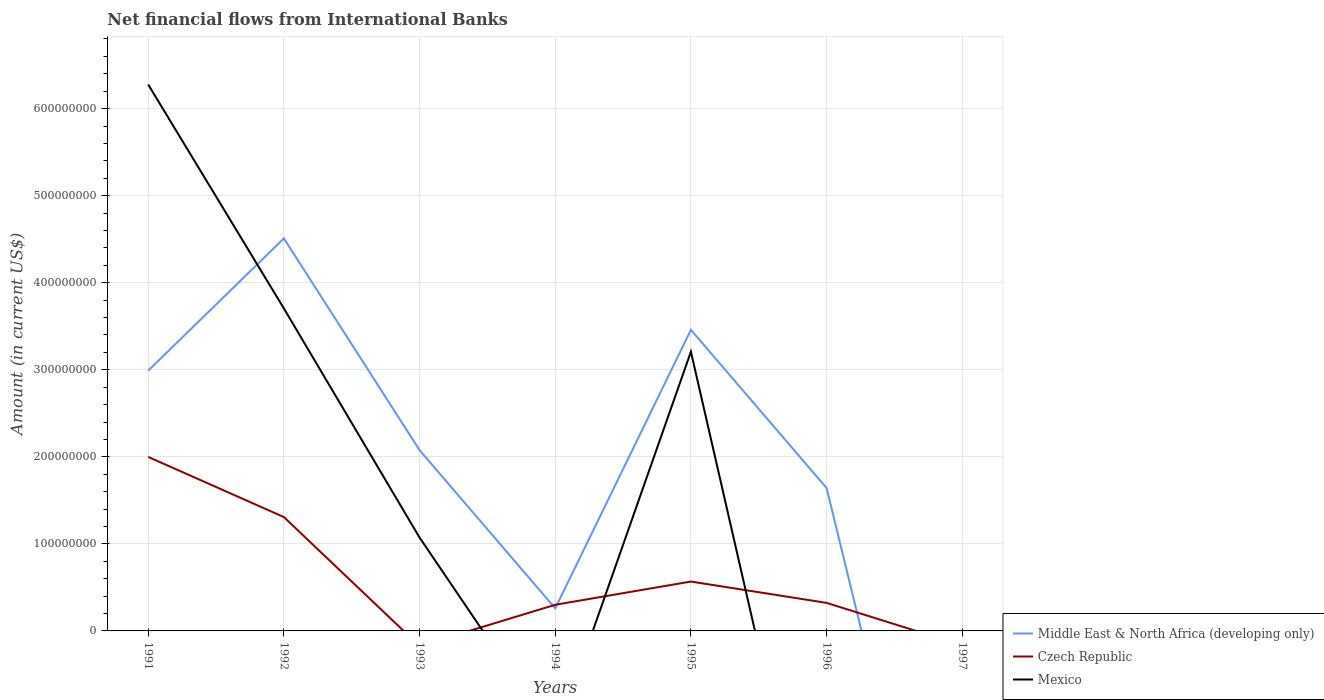What is the total net financial aid flows in Middle East & North Africa (developing only) in the graph?
Your answer should be very brief. 9.13e+07. What is the difference between the highest and the second highest net financial aid flows in Mexico?
Offer a very short reply. 6.28e+08. What is the difference between the highest and the lowest net financial aid flows in Czech Republic?
Offer a very short reply. 2. How many lines are there?
Give a very brief answer. 3. How many years are there in the graph?
Provide a succinct answer. 7. Does the graph contain any zero values?
Offer a very short reply. Yes. Does the graph contain grids?
Your answer should be very brief. Yes. How many legend labels are there?
Make the answer very short. 3. How are the legend labels stacked?
Offer a terse response. Vertical. What is the title of the graph?
Provide a succinct answer. Net financial flows from International Banks. Does "Belgium" appear as one of the legend labels in the graph?
Provide a succinct answer. No. What is the Amount (in current US$) in Middle East & North Africa (developing only) in 1991?
Provide a succinct answer. 2.99e+08. What is the Amount (in current US$) of Czech Republic in 1991?
Your answer should be very brief. 2.00e+08. What is the Amount (in current US$) in Mexico in 1991?
Make the answer very short. 6.28e+08. What is the Amount (in current US$) in Middle East & North Africa (developing only) in 1992?
Give a very brief answer. 4.51e+08. What is the Amount (in current US$) in Czech Republic in 1992?
Keep it short and to the point. 1.31e+08. What is the Amount (in current US$) in Mexico in 1992?
Give a very brief answer. 3.70e+08. What is the Amount (in current US$) in Middle East & North Africa (developing only) in 1993?
Provide a short and direct response. 2.08e+08. What is the Amount (in current US$) of Mexico in 1993?
Offer a terse response. 1.07e+08. What is the Amount (in current US$) of Middle East & North Africa (developing only) in 1994?
Provide a succinct answer. 2.59e+07. What is the Amount (in current US$) of Czech Republic in 1994?
Offer a very short reply. 3.00e+07. What is the Amount (in current US$) in Middle East & North Africa (developing only) in 1995?
Offer a very short reply. 3.46e+08. What is the Amount (in current US$) in Czech Republic in 1995?
Ensure brevity in your answer.  5.67e+07. What is the Amount (in current US$) of Mexico in 1995?
Offer a very short reply. 3.21e+08. What is the Amount (in current US$) in Middle East & North Africa (developing only) in 1996?
Your answer should be very brief. 1.64e+08. What is the Amount (in current US$) of Czech Republic in 1996?
Your response must be concise. 3.22e+07. What is the Amount (in current US$) in Middle East & North Africa (developing only) in 1997?
Make the answer very short. 0. What is the Amount (in current US$) of Czech Republic in 1997?
Keep it short and to the point. 0. Across all years, what is the maximum Amount (in current US$) of Middle East & North Africa (developing only)?
Offer a very short reply. 4.51e+08. Across all years, what is the maximum Amount (in current US$) of Czech Republic?
Provide a short and direct response. 2.00e+08. Across all years, what is the maximum Amount (in current US$) in Mexico?
Ensure brevity in your answer.  6.28e+08. What is the total Amount (in current US$) of Middle East & North Africa (developing only) in the graph?
Provide a succinct answer. 1.49e+09. What is the total Amount (in current US$) of Czech Republic in the graph?
Your response must be concise. 4.50e+08. What is the total Amount (in current US$) in Mexico in the graph?
Offer a terse response. 1.43e+09. What is the difference between the Amount (in current US$) in Middle East & North Africa (developing only) in 1991 and that in 1992?
Offer a very short reply. -1.52e+08. What is the difference between the Amount (in current US$) in Czech Republic in 1991 and that in 1992?
Make the answer very short. 6.91e+07. What is the difference between the Amount (in current US$) in Mexico in 1991 and that in 1992?
Ensure brevity in your answer.  2.57e+08. What is the difference between the Amount (in current US$) in Middle East & North Africa (developing only) in 1991 and that in 1993?
Your answer should be compact. 9.13e+07. What is the difference between the Amount (in current US$) in Mexico in 1991 and that in 1993?
Offer a very short reply. 5.20e+08. What is the difference between the Amount (in current US$) in Middle East & North Africa (developing only) in 1991 and that in 1994?
Make the answer very short. 2.73e+08. What is the difference between the Amount (in current US$) of Czech Republic in 1991 and that in 1994?
Your response must be concise. 1.70e+08. What is the difference between the Amount (in current US$) of Middle East & North Africa (developing only) in 1991 and that in 1995?
Your answer should be very brief. -4.69e+07. What is the difference between the Amount (in current US$) of Czech Republic in 1991 and that in 1995?
Keep it short and to the point. 1.43e+08. What is the difference between the Amount (in current US$) of Mexico in 1991 and that in 1995?
Your response must be concise. 3.07e+08. What is the difference between the Amount (in current US$) in Middle East & North Africa (developing only) in 1991 and that in 1996?
Give a very brief answer. 1.35e+08. What is the difference between the Amount (in current US$) of Czech Republic in 1991 and that in 1996?
Your response must be concise. 1.68e+08. What is the difference between the Amount (in current US$) of Middle East & North Africa (developing only) in 1992 and that in 1993?
Give a very brief answer. 2.43e+08. What is the difference between the Amount (in current US$) in Mexico in 1992 and that in 1993?
Make the answer very short. 2.63e+08. What is the difference between the Amount (in current US$) of Middle East & North Africa (developing only) in 1992 and that in 1994?
Offer a very short reply. 4.25e+08. What is the difference between the Amount (in current US$) in Czech Republic in 1992 and that in 1994?
Provide a short and direct response. 1.01e+08. What is the difference between the Amount (in current US$) in Middle East & North Africa (developing only) in 1992 and that in 1995?
Offer a very short reply. 1.05e+08. What is the difference between the Amount (in current US$) in Czech Republic in 1992 and that in 1995?
Offer a terse response. 7.41e+07. What is the difference between the Amount (in current US$) in Mexico in 1992 and that in 1995?
Keep it short and to the point. 4.97e+07. What is the difference between the Amount (in current US$) in Middle East & North Africa (developing only) in 1992 and that in 1996?
Offer a very short reply. 2.87e+08. What is the difference between the Amount (in current US$) in Czech Republic in 1992 and that in 1996?
Your response must be concise. 9.86e+07. What is the difference between the Amount (in current US$) of Middle East & North Africa (developing only) in 1993 and that in 1994?
Your answer should be very brief. 1.82e+08. What is the difference between the Amount (in current US$) of Middle East & North Africa (developing only) in 1993 and that in 1995?
Your response must be concise. -1.38e+08. What is the difference between the Amount (in current US$) of Mexico in 1993 and that in 1995?
Give a very brief answer. -2.13e+08. What is the difference between the Amount (in current US$) in Middle East & North Africa (developing only) in 1993 and that in 1996?
Make the answer very short. 4.35e+07. What is the difference between the Amount (in current US$) of Middle East & North Africa (developing only) in 1994 and that in 1995?
Keep it short and to the point. -3.20e+08. What is the difference between the Amount (in current US$) in Czech Republic in 1994 and that in 1995?
Offer a very short reply. -2.67e+07. What is the difference between the Amount (in current US$) of Middle East & North Africa (developing only) in 1994 and that in 1996?
Provide a succinct answer. -1.38e+08. What is the difference between the Amount (in current US$) in Czech Republic in 1994 and that in 1996?
Provide a succinct answer. -2.19e+06. What is the difference between the Amount (in current US$) of Middle East & North Africa (developing only) in 1995 and that in 1996?
Make the answer very short. 1.82e+08. What is the difference between the Amount (in current US$) in Czech Republic in 1995 and that in 1996?
Provide a succinct answer. 2.45e+07. What is the difference between the Amount (in current US$) in Middle East & North Africa (developing only) in 1991 and the Amount (in current US$) in Czech Republic in 1992?
Your response must be concise. 1.68e+08. What is the difference between the Amount (in current US$) in Middle East & North Africa (developing only) in 1991 and the Amount (in current US$) in Mexico in 1992?
Provide a succinct answer. -7.15e+07. What is the difference between the Amount (in current US$) in Czech Republic in 1991 and the Amount (in current US$) in Mexico in 1992?
Provide a succinct answer. -1.71e+08. What is the difference between the Amount (in current US$) in Middle East & North Africa (developing only) in 1991 and the Amount (in current US$) in Mexico in 1993?
Give a very brief answer. 1.92e+08. What is the difference between the Amount (in current US$) in Czech Republic in 1991 and the Amount (in current US$) in Mexico in 1993?
Ensure brevity in your answer.  9.26e+07. What is the difference between the Amount (in current US$) of Middle East & North Africa (developing only) in 1991 and the Amount (in current US$) of Czech Republic in 1994?
Offer a terse response. 2.69e+08. What is the difference between the Amount (in current US$) in Middle East & North Africa (developing only) in 1991 and the Amount (in current US$) in Czech Republic in 1995?
Provide a succinct answer. 2.42e+08. What is the difference between the Amount (in current US$) of Middle East & North Africa (developing only) in 1991 and the Amount (in current US$) of Mexico in 1995?
Ensure brevity in your answer.  -2.18e+07. What is the difference between the Amount (in current US$) in Czech Republic in 1991 and the Amount (in current US$) in Mexico in 1995?
Keep it short and to the point. -1.21e+08. What is the difference between the Amount (in current US$) in Middle East & North Africa (developing only) in 1991 and the Amount (in current US$) in Czech Republic in 1996?
Give a very brief answer. 2.67e+08. What is the difference between the Amount (in current US$) in Middle East & North Africa (developing only) in 1992 and the Amount (in current US$) in Mexico in 1993?
Provide a succinct answer. 3.44e+08. What is the difference between the Amount (in current US$) in Czech Republic in 1992 and the Amount (in current US$) in Mexico in 1993?
Provide a succinct answer. 2.35e+07. What is the difference between the Amount (in current US$) in Middle East & North Africa (developing only) in 1992 and the Amount (in current US$) in Czech Republic in 1994?
Provide a short and direct response. 4.21e+08. What is the difference between the Amount (in current US$) of Middle East & North Africa (developing only) in 1992 and the Amount (in current US$) of Czech Republic in 1995?
Make the answer very short. 3.94e+08. What is the difference between the Amount (in current US$) in Middle East & North Africa (developing only) in 1992 and the Amount (in current US$) in Mexico in 1995?
Provide a short and direct response. 1.30e+08. What is the difference between the Amount (in current US$) of Czech Republic in 1992 and the Amount (in current US$) of Mexico in 1995?
Provide a succinct answer. -1.90e+08. What is the difference between the Amount (in current US$) of Middle East & North Africa (developing only) in 1992 and the Amount (in current US$) of Czech Republic in 1996?
Make the answer very short. 4.19e+08. What is the difference between the Amount (in current US$) of Middle East & North Africa (developing only) in 1993 and the Amount (in current US$) of Czech Republic in 1994?
Your answer should be compact. 1.78e+08. What is the difference between the Amount (in current US$) in Middle East & North Africa (developing only) in 1993 and the Amount (in current US$) in Czech Republic in 1995?
Ensure brevity in your answer.  1.51e+08. What is the difference between the Amount (in current US$) in Middle East & North Africa (developing only) in 1993 and the Amount (in current US$) in Mexico in 1995?
Make the answer very short. -1.13e+08. What is the difference between the Amount (in current US$) of Middle East & North Africa (developing only) in 1993 and the Amount (in current US$) of Czech Republic in 1996?
Make the answer very short. 1.75e+08. What is the difference between the Amount (in current US$) in Middle East & North Africa (developing only) in 1994 and the Amount (in current US$) in Czech Republic in 1995?
Give a very brief answer. -3.08e+07. What is the difference between the Amount (in current US$) in Middle East & North Africa (developing only) in 1994 and the Amount (in current US$) in Mexico in 1995?
Your response must be concise. -2.95e+08. What is the difference between the Amount (in current US$) in Czech Republic in 1994 and the Amount (in current US$) in Mexico in 1995?
Offer a terse response. -2.91e+08. What is the difference between the Amount (in current US$) in Middle East & North Africa (developing only) in 1994 and the Amount (in current US$) in Czech Republic in 1996?
Offer a terse response. -6.27e+06. What is the difference between the Amount (in current US$) of Middle East & North Africa (developing only) in 1995 and the Amount (in current US$) of Czech Republic in 1996?
Ensure brevity in your answer.  3.14e+08. What is the average Amount (in current US$) of Middle East & North Africa (developing only) per year?
Offer a terse response. 2.13e+08. What is the average Amount (in current US$) in Czech Republic per year?
Your answer should be very brief. 6.42e+07. What is the average Amount (in current US$) of Mexico per year?
Make the answer very short. 2.04e+08. In the year 1991, what is the difference between the Amount (in current US$) of Middle East & North Africa (developing only) and Amount (in current US$) of Czech Republic?
Offer a very short reply. 9.91e+07. In the year 1991, what is the difference between the Amount (in current US$) in Middle East & North Africa (developing only) and Amount (in current US$) in Mexico?
Offer a terse response. -3.29e+08. In the year 1991, what is the difference between the Amount (in current US$) of Czech Republic and Amount (in current US$) of Mexico?
Keep it short and to the point. -4.28e+08. In the year 1992, what is the difference between the Amount (in current US$) in Middle East & North Africa (developing only) and Amount (in current US$) in Czech Republic?
Ensure brevity in your answer.  3.20e+08. In the year 1992, what is the difference between the Amount (in current US$) in Middle East & North Africa (developing only) and Amount (in current US$) in Mexico?
Offer a terse response. 8.04e+07. In the year 1992, what is the difference between the Amount (in current US$) in Czech Republic and Amount (in current US$) in Mexico?
Give a very brief answer. -2.40e+08. In the year 1993, what is the difference between the Amount (in current US$) of Middle East & North Africa (developing only) and Amount (in current US$) of Mexico?
Your answer should be compact. 1.00e+08. In the year 1994, what is the difference between the Amount (in current US$) of Middle East & North Africa (developing only) and Amount (in current US$) of Czech Republic?
Your response must be concise. -4.08e+06. In the year 1995, what is the difference between the Amount (in current US$) in Middle East & North Africa (developing only) and Amount (in current US$) in Czech Republic?
Provide a succinct answer. 2.89e+08. In the year 1995, what is the difference between the Amount (in current US$) of Middle East & North Africa (developing only) and Amount (in current US$) of Mexico?
Provide a short and direct response. 2.51e+07. In the year 1995, what is the difference between the Amount (in current US$) in Czech Republic and Amount (in current US$) in Mexico?
Provide a short and direct response. -2.64e+08. In the year 1996, what is the difference between the Amount (in current US$) in Middle East & North Africa (developing only) and Amount (in current US$) in Czech Republic?
Provide a succinct answer. 1.32e+08. What is the ratio of the Amount (in current US$) in Middle East & North Africa (developing only) in 1991 to that in 1992?
Provide a short and direct response. 0.66. What is the ratio of the Amount (in current US$) in Czech Republic in 1991 to that in 1992?
Your answer should be compact. 1.53. What is the ratio of the Amount (in current US$) of Mexico in 1991 to that in 1992?
Give a very brief answer. 1.69. What is the ratio of the Amount (in current US$) in Middle East & North Africa (developing only) in 1991 to that in 1993?
Ensure brevity in your answer.  1.44. What is the ratio of the Amount (in current US$) in Mexico in 1991 to that in 1993?
Offer a terse response. 5.85. What is the ratio of the Amount (in current US$) in Middle East & North Africa (developing only) in 1991 to that in 1994?
Offer a terse response. 11.52. What is the ratio of the Amount (in current US$) in Czech Republic in 1991 to that in 1994?
Give a very brief answer. 6.66. What is the ratio of the Amount (in current US$) of Middle East & North Africa (developing only) in 1991 to that in 1995?
Offer a very short reply. 0.86. What is the ratio of the Amount (in current US$) of Czech Republic in 1991 to that in 1995?
Provide a succinct answer. 3.52. What is the ratio of the Amount (in current US$) in Mexico in 1991 to that in 1995?
Provide a succinct answer. 1.96. What is the ratio of the Amount (in current US$) of Middle East & North Africa (developing only) in 1991 to that in 1996?
Your answer should be compact. 1.82. What is the ratio of the Amount (in current US$) in Czech Republic in 1991 to that in 1996?
Give a very brief answer. 6.21. What is the ratio of the Amount (in current US$) in Middle East & North Africa (developing only) in 1992 to that in 1993?
Offer a terse response. 2.17. What is the ratio of the Amount (in current US$) of Mexico in 1992 to that in 1993?
Offer a very short reply. 3.45. What is the ratio of the Amount (in current US$) in Middle East & North Africa (developing only) in 1992 to that in 1994?
Give a very brief answer. 17.38. What is the ratio of the Amount (in current US$) in Czech Republic in 1992 to that in 1994?
Your response must be concise. 4.36. What is the ratio of the Amount (in current US$) in Middle East & North Africa (developing only) in 1992 to that in 1995?
Keep it short and to the point. 1.3. What is the ratio of the Amount (in current US$) of Czech Republic in 1992 to that in 1995?
Provide a succinct answer. 2.31. What is the ratio of the Amount (in current US$) in Mexico in 1992 to that in 1995?
Ensure brevity in your answer.  1.16. What is the ratio of the Amount (in current US$) in Middle East & North Africa (developing only) in 1992 to that in 1996?
Ensure brevity in your answer.  2.75. What is the ratio of the Amount (in current US$) of Czech Republic in 1992 to that in 1996?
Give a very brief answer. 4.06. What is the ratio of the Amount (in current US$) in Middle East & North Africa (developing only) in 1993 to that in 1994?
Keep it short and to the point. 8. What is the ratio of the Amount (in current US$) of Middle East & North Africa (developing only) in 1993 to that in 1995?
Provide a succinct answer. 0.6. What is the ratio of the Amount (in current US$) of Mexico in 1993 to that in 1995?
Ensure brevity in your answer.  0.33. What is the ratio of the Amount (in current US$) of Middle East & North Africa (developing only) in 1993 to that in 1996?
Your response must be concise. 1.27. What is the ratio of the Amount (in current US$) in Middle East & North Africa (developing only) in 1994 to that in 1995?
Offer a terse response. 0.07. What is the ratio of the Amount (in current US$) in Czech Republic in 1994 to that in 1995?
Your response must be concise. 0.53. What is the ratio of the Amount (in current US$) in Middle East & North Africa (developing only) in 1994 to that in 1996?
Provide a short and direct response. 0.16. What is the ratio of the Amount (in current US$) of Czech Republic in 1994 to that in 1996?
Offer a very short reply. 0.93. What is the ratio of the Amount (in current US$) in Middle East & North Africa (developing only) in 1995 to that in 1996?
Provide a short and direct response. 2.11. What is the ratio of the Amount (in current US$) in Czech Republic in 1995 to that in 1996?
Provide a short and direct response. 1.76. What is the difference between the highest and the second highest Amount (in current US$) in Middle East & North Africa (developing only)?
Offer a very short reply. 1.05e+08. What is the difference between the highest and the second highest Amount (in current US$) of Czech Republic?
Provide a succinct answer. 6.91e+07. What is the difference between the highest and the second highest Amount (in current US$) of Mexico?
Keep it short and to the point. 2.57e+08. What is the difference between the highest and the lowest Amount (in current US$) in Middle East & North Africa (developing only)?
Offer a terse response. 4.51e+08. What is the difference between the highest and the lowest Amount (in current US$) in Czech Republic?
Provide a succinct answer. 2.00e+08. What is the difference between the highest and the lowest Amount (in current US$) of Mexico?
Offer a terse response. 6.28e+08. 